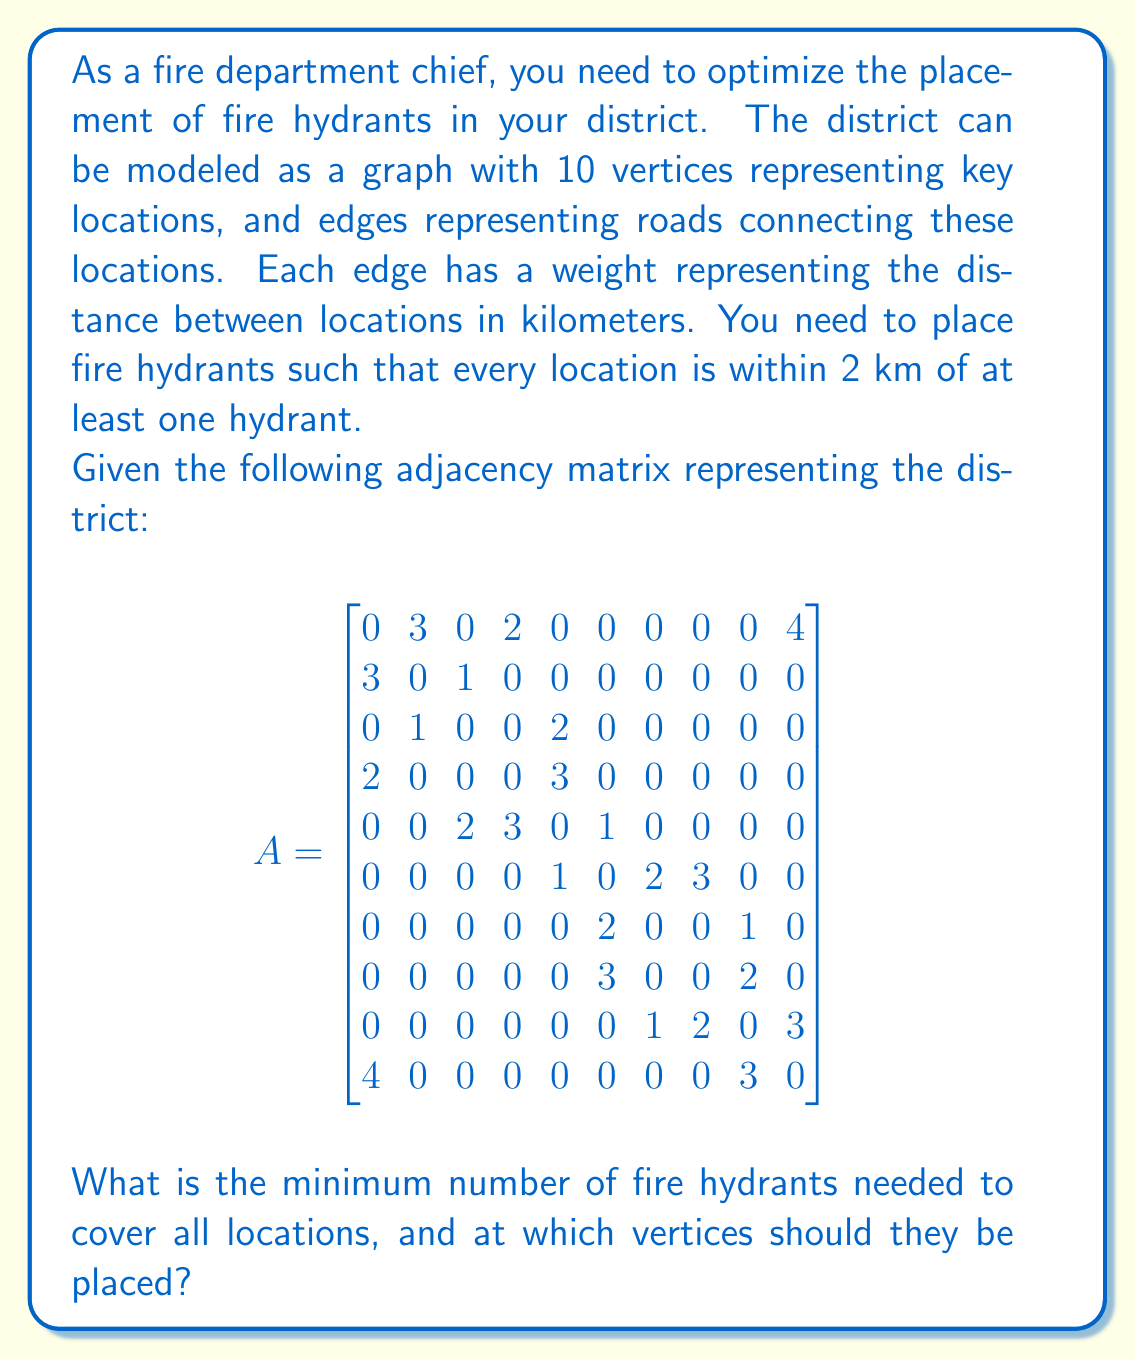What is the answer to this math problem? To solve this problem, we need to find the minimum dominating set of the graph with a distance constraint of 2 km. Here's how we can approach this:

1) First, we need to create a new graph where two vertices are connected if they are within 2 km of each other. We can do this by squaring the adjacency matrix and setting all non-zero entries to 1:

   $$A^2 = A \times A$$
   
   Then, we add this to the original adjacency matrix and set all non-zero entries to 1:
   
   $$B = (A + A^2 > 0)$$

2) Now, we need to find the minimum dominating set of this new graph B. This is an NP-hard problem, but for a small graph like this, we can use a greedy algorithm:

   a) Start with an empty set S of vertices.
   b) While there are uncovered vertices:
      - Choose the vertex that covers the most uncovered vertices.
      - Add this vertex to S.
      - Mark all vertices covered by this vertex as covered.

3) Implementing this algorithm on our graph:

   - Vertex 5 covers 6 vertices (2, 3, 4, 5, 6, 7)
   - Vertex 9 covers the remaining 4 vertices (1, 8, 9, 10)

Therefore, we need to place fire hydrants at vertices 5 and 9 to cover all locations within 2 km.
Answer: The minimum number of fire hydrants needed is 2, and they should be placed at vertices 5 and 9. 